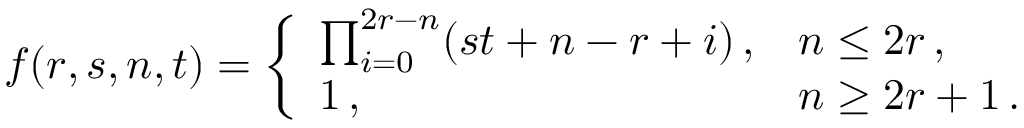<formula> <loc_0><loc_0><loc_500><loc_500>f ( r , s , n , t ) = \left \{ \begin{array} { l l } { { \prod _ { i = 0 } ^ { 2 r - n } ( s t + n - r + i ) \, , } } & { n \leq 2 r \, , } \\ { 1 \, , } & { n \geq 2 r + 1 \, . } \end{array}</formula> 